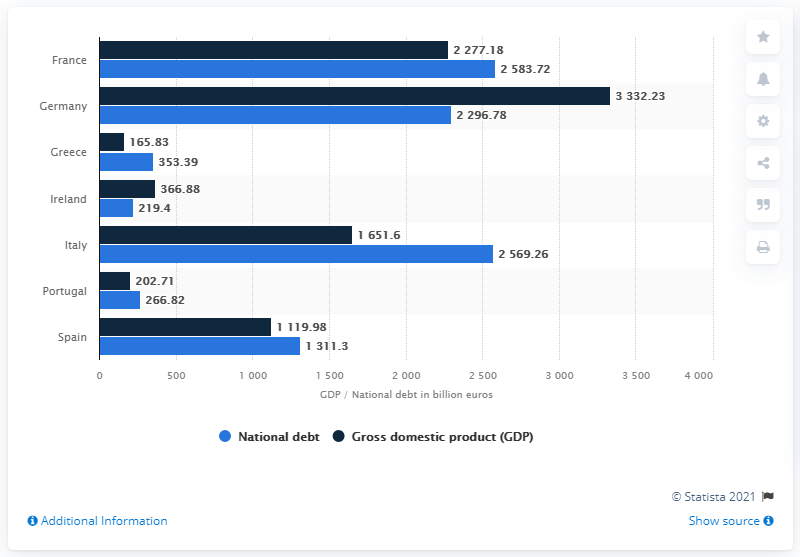Identify some key points in this picture. In 2020, Italy's national debt was 2583.72. In 2020, the Gross Domestic Product (GDP) of Italy was 1651.6 billion dollars. 